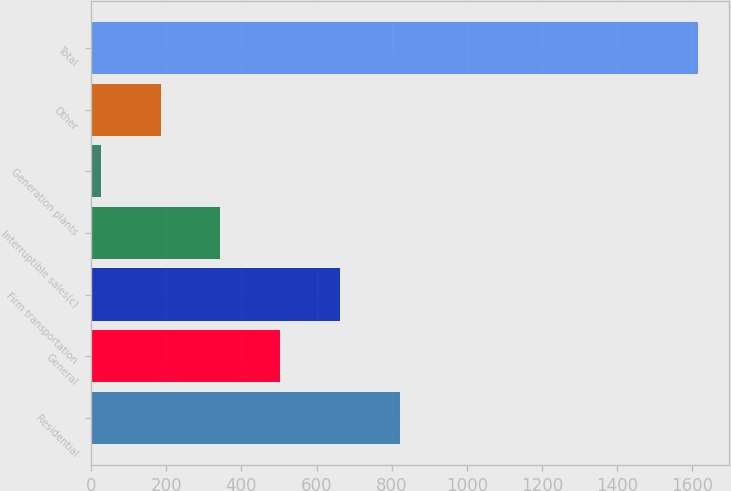<chart> <loc_0><loc_0><loc_500><loc_500><bar_chart><fcel>Residential<fcel>General<fcel>Firm transportation<fcel>Interruptible sales(c)<fcel>Generation plants<fcel>Other<fcel>Total<nl><fcel>821<fcel>503<fcel>662<fcel>344<fcel>26<fcel>185<fcel>1616<nl></chart> 